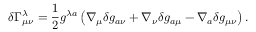Convert formula to latex. <formula><loc_0><loc_0><loc_500><loc_500>\delta \Gamma _ { \mu \nu } ^ { \lambda } = { \frac { 1 } { 2 } } g ^ { \lambda a } \left ( \nabla _ { \mu } \delta g _ { a \nu } + \nabla _ { \nu } \delta g _ { a \mu } - \nabla _ { a } \delta g _ { \mu \nu } \right ) .</formula> 